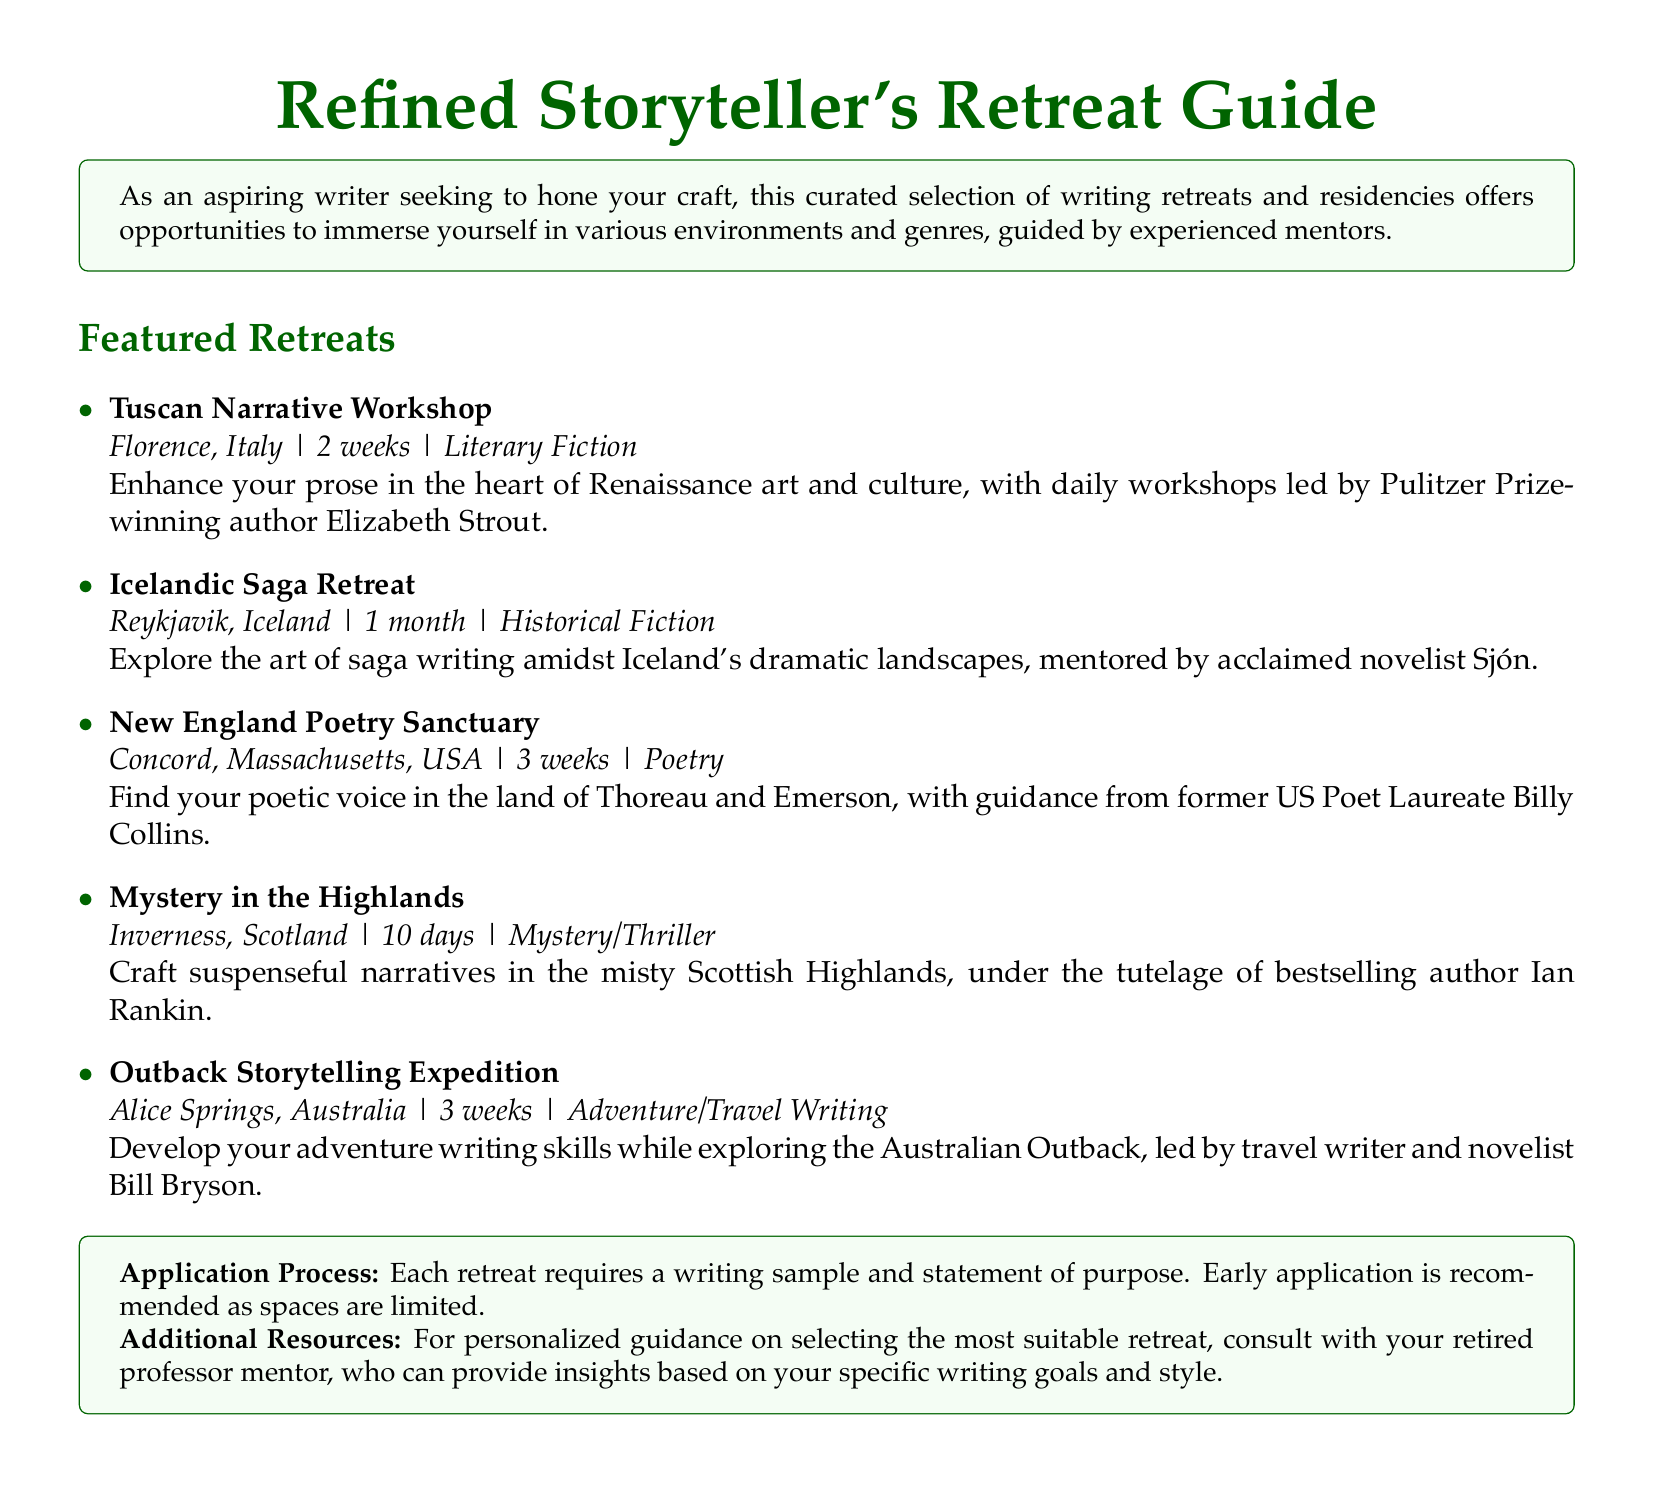What is the duration of the Tuscan Narrative Workshop? The duration of the Tuscan Narrative Workshop is specified as 2 weeks.
Answer: 2 weeks Who is the mentor for the Icelandic Saga Retreat? The mentor for the Icelandic Saga Retreat is mentioned as acclaimed novelist Sjón.
Answer: Sjón In which city does the New England Poetry Sanctuary take place? The city for the New England Poetry Sanctuary is Concord, Massachusetts, USA.
Answer: Concord, Massachusetts, USA How long is the Mystery in the Highlands retreat? The duration of the Mystery in the Highlands retreat is listed as 10 days.
Answer: 10 days What genre focus does the Outback Storytelling Expedition have? The genre focus of the Outback Storytelling Expedition is Adventure/Travel Writing.
Answer: Adventure/Travel Writing How many weeks is the duration of the New England Poetry Sanctuary? The document states that the duration of the New England Poetry Sanctuary is 3 weeks.
Answer: 3 weeks What is the common requirement for applying to each retreat? The common requirement mentioned for applying to each retreat includes a writing sample and statement of purpose.
Answer: Writing sample and statement of purpose Who is the guiding mentor for the New England Poetry Sanctuary? The guiding mentor for the New England Poetry Sanctuary is former US Poet Laureate Billy Collins.
Answer: Billy Collins What is the recommended application strategy mentioned in the document? The document recommends early application as spaces are limited.
Answer: Early application 